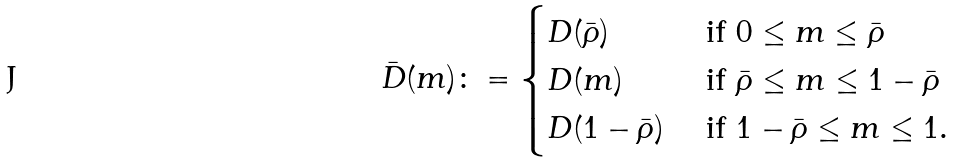<formula> <loc_0><loc_0><loc_500><loc_500>\bar { D } ( m ) \colon = \begin{cases} D ( \bar { \rho } ) & \text { if } 0 \leq m \leq \bar { \rho } \\ D ( m ) & \text { if } \bar { \rho } \leq m \leq 1 - \bar { \rho } \\ D ( 1 - \bar { \rho } ) & \text { if } 1 - \bar { \rho } \leq m \leq 1 . \end{cases}</formula> 